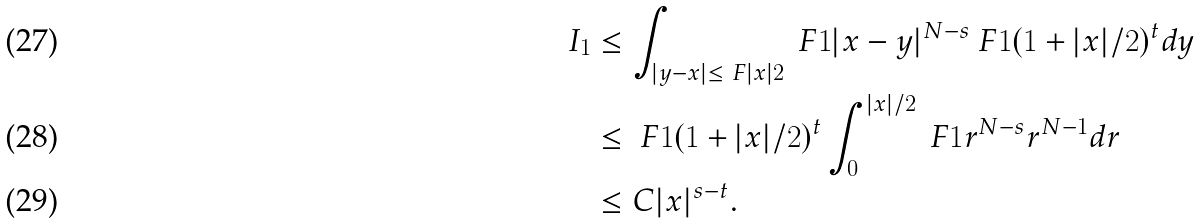<formula> <loc_0><loc_0><loc_500><loc_500>I _ { 1 } & \leq \int _ { | y - x | \leq \ F { | x | } { 2 } } \ F { 1 } { | x - y | ^ { N - s } } \ F { 1 } { ( 1 + | x | / 2 ) ^ { t } } d y \\ & \leq \ F { 1 } { ( 1 + | x | / 2 ) ^ { t } } \int _ { 0 } ^ { | x | / 2 } \ F { 1 } { r ^ { N - s } } r ^ { N - 1 } d r \\ & \leq C | x | ^ { s - t } .</formula> 